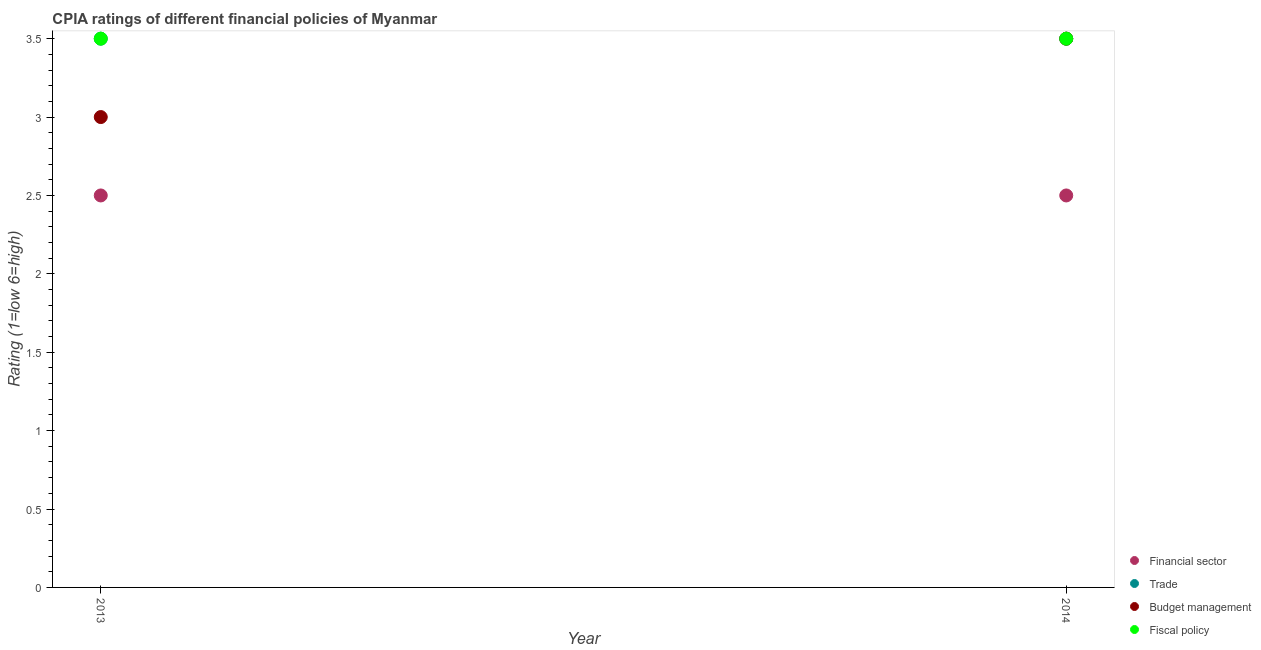How many different coloured dotlines are there?
Provide a short and direct response. 4. What is the cpia rating of budget management in 2013?
Your response must be concise. 3. In which year was the cpia rating of fiscal policy minimum?
Keep it short and to the point. 2013. In the year 2014, what is the difference between the cpia rating of trade and cpia rating of financial sector?
Provide a short and direct response. 1. In how many years, is the cpia rating of fiscal policy greater than 3?
Your answer should be compact. 2. What is the ratio of the cpia rating of fiscal policy in 2013 to that in 2014?
Keep it short and to the point. 1. Is the cpia rating of fiscal policy in 2013 less than that in 2014?
Provide a short and direct response. No. Is it the case that in every year, the sum of the cpia rating of financial sector and cpia rating of trade is greater than the cpia rating of budget management?
Give a very brief answer. Yes. Does the cpia rating of financial sector monotonically increase over the years?
Provide a short and direct response. No. What is the difference between two consecutive major ticks on the Y-axis?
Provide a short and direct response. 0.5. Does the graph contain any zero values?
Give a very brief answer. No. Does the graph contain grids?
Offer a very short reply. No. Where does the legend appear in the graph?
Ensure brevity in your answer.  Bottom right. What is the title of the graph?
Offer a very short reply. CPIA ratings of different financial policies of Myanmar. Does "Tertiary schools" appear as one of the legend labels in the graph?
Provide a succinct answer. No. What is the label or title of the X-axis?
Keep it short and to the point. Year. What is the label or title of the Y-axis?
Your answer should be compact. Rating (1=low 6=high). What is the Rating (1=low 6=high) in Financial sector in 2013?
Provide a short and direct response. 2.5. What is the Rating (1=low 6=high) in Financial sector in 2014?
Your response must be concise. 2.5. What is the Rating (1=low 6=high) of Trade in 2014?
Keep it short and to the point. 3.5. What is the Rating (1=low 6=high) in Budget management in 2014?
Provide a short and direct response. 3.5. What is the Rating (1=low 6=high) in Fiscal policy in 2014?
Make the answer very short. 3.5. Across all years, what is the maximum Rating (1=low 6=high) of Financial sector?
Your answer should be compact. 2.5. Across all years, what is the maximum Rating (1=low 6=high) of Fiscal policy?
Provide a short and direct response. 3.5. Across all years, what is the minimum Rating (1=low 6=high) of Fiscal policy?
Keep it short and to the point. 3.5. What is the total Rating (1=low 6=high) of Budget management in the graph?
Ensure brevity in your answer.  6.5. What is the difference between the Rating (1=low 6=high) in Fiscal policy in 2013 and that in 2014?
Your answer should be very brief. 0. What is the difference between the Rating (1=low 6=high) in Financial sector in 2013 and the Rating (1=low 6=high) in Trade in 2014?
Ensure brevity in your answer.  -1. What is the difference between the Rating (1=low 6=high) in Financial sector in 2013 and the Rating (1=low 6=high) in Fiscal policy in 2014?
Make the answer very short. -1. What is the difference between the Rating (1=low 6=high) of Trade in 2013 and the Rating (1=low 6=high) of Fiscal policy in 2014?
Offer a terse response. 0. What is the average Rating (1=low 6=high) in Trade per year?
Ensure brevity in your answer.  3.5. What is the average Rating (1=low 6=high) in Budget management per year?
Provide a short and direct response. 3.25. What is the average Rating (1=low 6=high) of Fiscal policy per year?
Make the answer very short. 3.5. In the year 2013, what is the difference between the Rating (1=low 6=high) in Financial sector and Rating (1=low 6=high) in Trade?
Make the answer very short. -1. In the year 2013, what is the difference between the Rating (1=low 6=high) in Financial sector and Rating (1=low 6=high) in Budget management?
Keep it short and to the point. -0.5. In the year 2013, what is the difference between the Rating (1=low 6=high) of Budget management and Rating (1=low 6=high) of Fiscal policy?
Provide a succinct answer. -0.5. In the year 2014, what is the difference between the Rating (1=low 6=high) in Trade and Rating (1=low 6=high) in Budget management?
Provide a short and direct response. 0. What is the ratio of the Rating (1=low 6=high) in Financial sector in 2013 to that in 2014?
Provide a succinct answer. 1. What is the ratio of the Rating (1=low 6=high) of Fiscal policy in 2013 to that in 2014?
Offer a very short reply. 1. What is the difference between the highest and the second highest Rating (1=low 6=high) in Fiscal policy?
Give a very brief answer. 0. What is the difference between the highest and the lowest Rating (1=low 6=high) in Budget management?
Keep it short and to the point. 0.5. What is the difference between the highest and the lowest Rating (1=low 6=high) in Fiscal policy?
Keep it short and to the point. 0. 